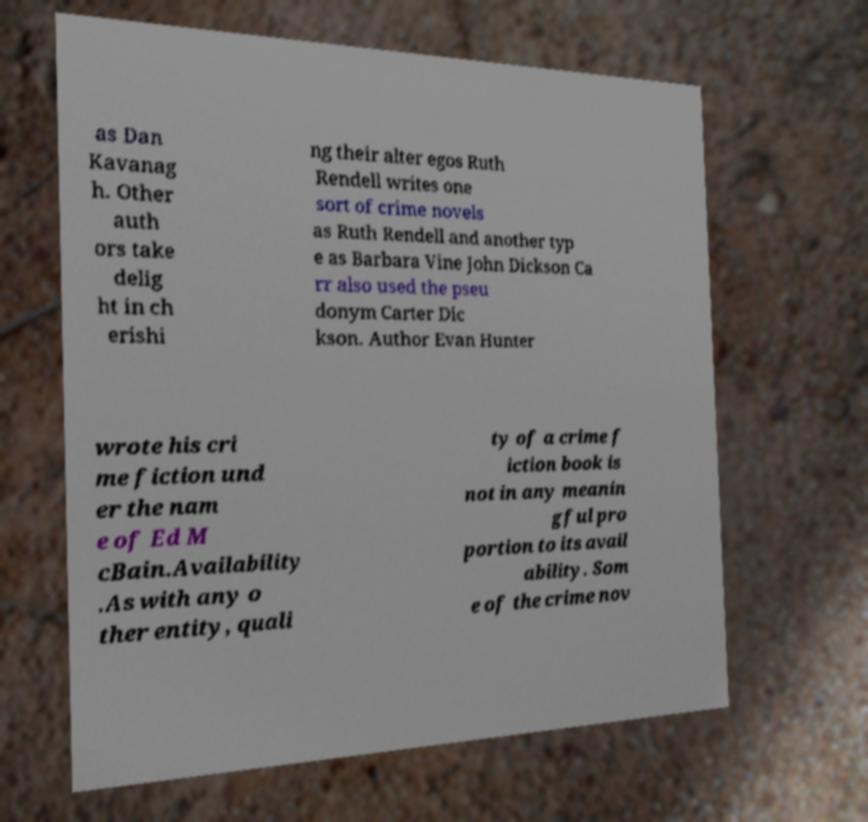I need the written content from this picture converted into text. Can you do that? as Dan Kavanag h. Other auth ors take delig ht in ch erishi ng their alter egos Ruth Rendell writes one sort of crime novels as Ruth Rendell and another typ e as Barbara Vine John Dickson Ca rr also used the pseu donym Carter Dic kson. Author Evan Hunter wrote his cri me fiction und er the nam e of Ed M cBain.Availability .As with any o ther entity, quali ty of a crime f iction book is not in any meanin gful pro portion to its avail ability. Som e of the crime nov 